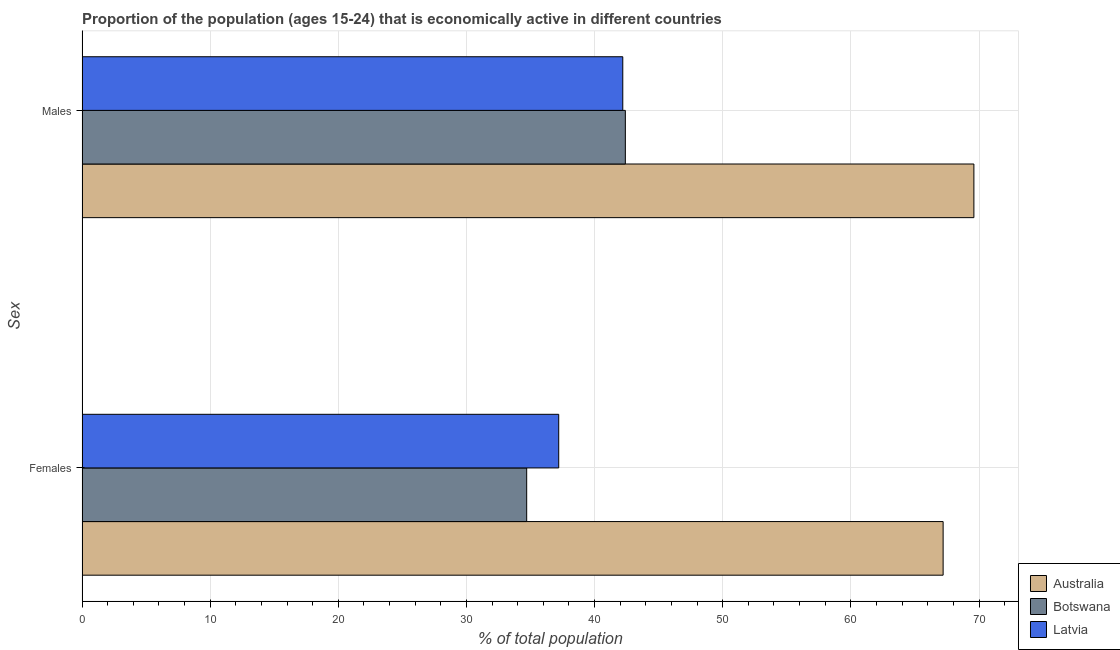How many different coloured bars are there?
Keep it short and to the point. 3. Are the number of bars on each tick of the Y-axis equal?
Your answer should be very brief. Yes. How many bars are there on the 1st tick from the top?
Your answer should be very brief. 3. What is the label of the 1st group of bars from the top?
Ensure brevity in your answer.  Males. What is the percentage of economically active female population in Australia?
Offer a very short reply. 67.2. Across all countries, what is the maximum percentage of economically active female population?
Provide a short and direct response. 67.2. Across all countries, what is the minimum percentage of economically active male population?
Offer a very short reply. 42.2. In which country was the percentage of economically active male population minimum?
Give a very brief answer. Latvia. What is the total percentage of economically active male population in the graph?
Your answer should be compact. 154.2. What is the difference between the percentage of economically active male population in Australia and that in Latvia?
Provide a short and direct response. 27.4. What is the difference between the percentage of economically active female population in Latvia and the percentage of economically active male population in Australia?
Your answer should be compact. -32.4. What is the average percentage of economically active female population per country?
Your answer should be compact. 46.37. What is the difference between the percentage of economically active male population and percentage of economically active female population in Botswana?
Ensure brevity in your answer.  7.7. In how many countries, is the percentage of economically active female population greater than 50 %?
Your answer should be compact. 1. What is the ratio of the percentage of economically active female population in Australia to that in Botswana?
Your answer should be compact. 1.94. What does the 2nd bar from the top in Females represents?
Offer a very short reply. Botswana. What does the 3rd bar from the bottom in Females represents?
Make the answer very short. Latvia. How many bars are there?
Your answer should be compact. 6. Are all the bars in the graph horizontal?
Make the answer very short. Yes. How many countries are there in the graph?
Provide a short and direct response. 3. What is the difference between two consecutive major ticks on the X-axis?
Keep it short and to the point. 10. Does the graph contain grids?
Offer a very short reply. Yes. Where does the legend appear in the graph?
Give a very brief answer. Bottom right. What is the title of the graph?
Give a very brief answer. Proportion of the population (ages 15-24) that is economically active in different countries. Does "Brunei Darussalam" appear as one of the legend labels in the graph?
Offer a very short reply. No. What is the label or title of the X-axis?
Your answer should be compact. % of total population. What is the label or title of the Y-axis?
Provide a succinct answer. Sex. What is the % of total population in Australia in Females?
Your response must be concise. 67.2. What is the % of total population in Botswana in Females?
Provide a short and direct response. 34.7. What is the % of total population in Latvia in Females?
Provide a short and direct response. 37.2. What is the % of total population of Australia in Males?
Provide a succinct answer. 69.6. What is the % of total population in Botswana in Males?
Provide a succinct answer. 42.4. What is the % of total population in Latvia in Males?
Keep it short and to the point. 42.2. Across all Sex, what is the maximum % of total population in Australia?
Your response must be concise. 69.6. Across all Sex, what is the maximum % of total population in Botswana?
Give a very brief answer. 42.4. Across all Sex, what is the maximum % of total population in Latvia?
Offer a terse response. 42.2. Across all Sex, what is the minimum % of total population of Australia?
Give a very brief answer. 67.2. Across all Sex, what is the minimum % of total population of Botswana?
Provide a succinct answer. 34.7. Across all Sex, what is the minimum % of total population in Latvia?
Offer a very short reply. 37.2. What is the total % of total population in Australia in the graph?
Offer a terse response. 136.8. What is the total % of total population of Botswana in the graph?
Keep it short and to the point. 77.1. What is the total % of total population of Latvia in the graph?
Make the answer very short. 79.4. What is the difference between the % of total population in Latvia in Females and that in Males?
Your answer should be compact. -5. What is the difference between the % of total population of Australia in Females and the % of total population of Botswana in Males?
Your response must be concise. 24.8. What is the difference between the % of total population of Australia in Females and the % of total population of Latvia in Males?
Keep it short and to the point. 25. What is the average % of total population in Australia per Sex?
Give a very brief answer. 68.4. What is the average % of total population in Botswana per Sex?
Make the answer very short. 38.55. What is the average % of total population in Latvia per Sex?
Ensure brevity in your answer.  39.7. What is the difference between the % of total population in Australia and % of total population in Botswana in Females?
Your answer should be compact. 32.5. What is the difference between the % of total population in Australia and % of total population in Latvia in Females?
Your answer should be very brief. 30. What is the difference between the % of total population in Botswana and % of total population in Latvia in Females?
Offer a terse response. -2.5. What is the difference between the % of total population in Australia and % of total population in Botswana in Males?
Give a very brief answer. 27.2. What is the difference between the % of total population in Australia and % of total population in Latvia in Males?
Offer a terse response. 27.4. What is the ratio of the % of total population of Australia in Females to that in Males?
Offer a very short reply. 0.97. What is the ratio of the % of total population in Botswana in Females to that in Males?
Provide a short and direct response. 0.82. What is the ratio of the % of total population of Latvia in Females to that in Males?
Provide a succinct answer. 0.88. What is the difference between the highest and the second highest % of total population of Australia?
Give a very brief answer. 2.4. What is the difference between the highest and the second highest % of total population in Botswana?
Make the answer very short. 7.7. What is the difference between the highest and the second highest % of total population of Latvia?
Your response must be concise. 5. What is the difference between the highest and the lowest % of total population of Botswana?
Your answer should be compact. 7.7. What is the difference between the highest and the lowest % of total population in Latvia?
Keep it short and to the point. 5. 